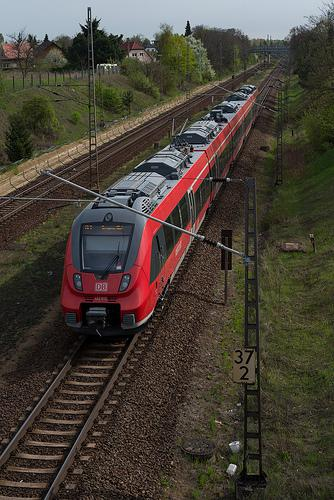Question: how many trains are in the picture?
Choices:
A. Two.
B. Three.
C. Four.
D. One.
Answer with the letter. Answer: D Question: what color is the train, predominantly?
Choices:
A. Yellow.
B. White.
C. Brown.
D. Red.
Answer with the letter. Answer: D Question: how many sets of tracks are visible?
Choices:
A. One.
B. Three.
C. Four.
D. Two.
Answer with the letter. Answer: D Question: where was this picture taken?
Choices:
A. Rail station.
B. Train tracks.
C. Railroad bridge.
D. Tunnel.
Answer with the letter. Answer: B 